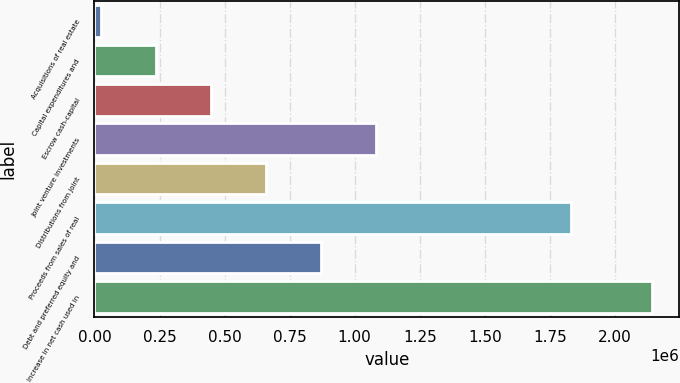Convert chart. <chart><loc_0><loc_0><loc_500><loc_500><bar_chart><fcel>Acquisitions of real estate<fcel>Capital expenditures and<fcel>Escrow cash-capital<fcel>Joint venture investments<fcel>Distributions from joint<fcel>Proceeds from sales of real<fcel>Debt and preferred equity and<fcel>Increase in net cash used in<nl><fcel>24080<fcel>235814<fcel>447548<fcel>1.08275e+06<fcel>659282<fcel>1.83004e+06<fcel>871016<fcel>2.14142e+06<nl></chart> 